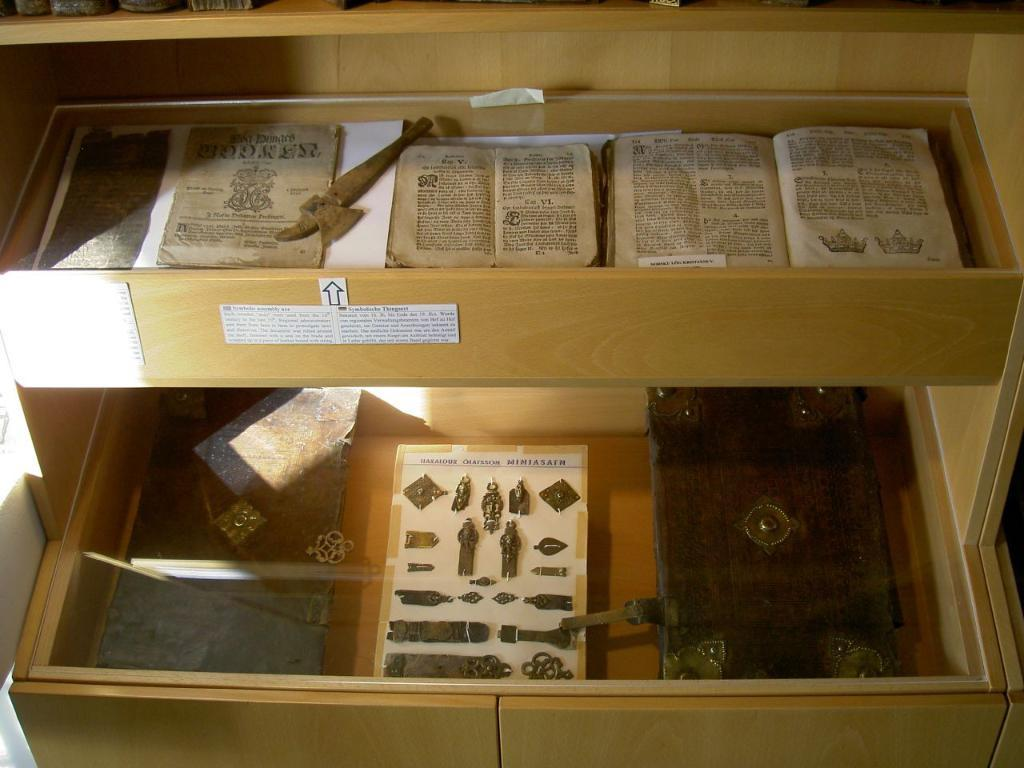What type of items can be seen in the image? There are books and other objects in the image. How are the books and other objects arranged in the image? The books and other objects are kept in racks. Where are the racks located in the image? The racks are in the middle of the image. What type of game is being played in the image? There is no game being played in the image; it features books and other objects kept in racks. 